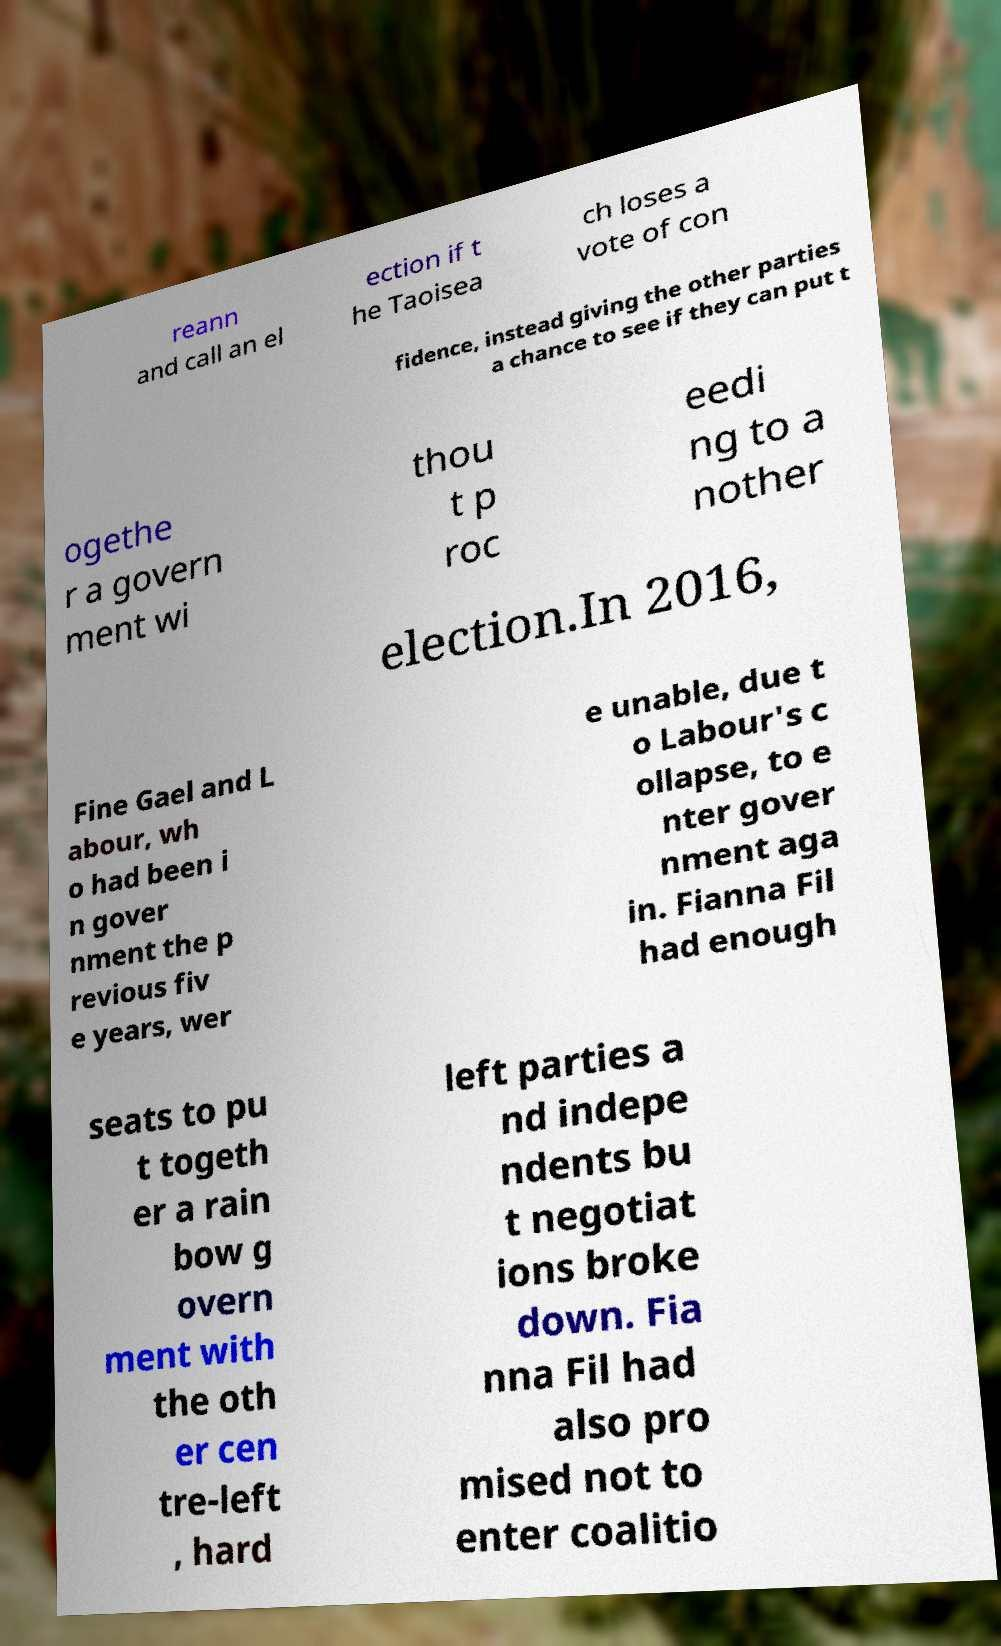I need the written content from this picture converted into text. Can you do that? reann and call an el ection if t he Taoisea ch loses a vote of con fidence, instead giving the other parties a chance to see if they can put t ogethe r a govern ment wi thou t p roc eedi ng to a nother election.In 2016, Fine Gael and L abour, wh o had been i n gover nment the p revious fiv e years, wer e unable, due t o Labour's c ollapse, to e nter gover nment aga in. Fianna Fil had enough seats to pu t togeth er a rain bow g overn ment with the oth er cen tre-left , hard left parties a nd indepe ndents bu t negotiat ions broke down. Fia nna Fil had also pro mised not to enter coalitio 